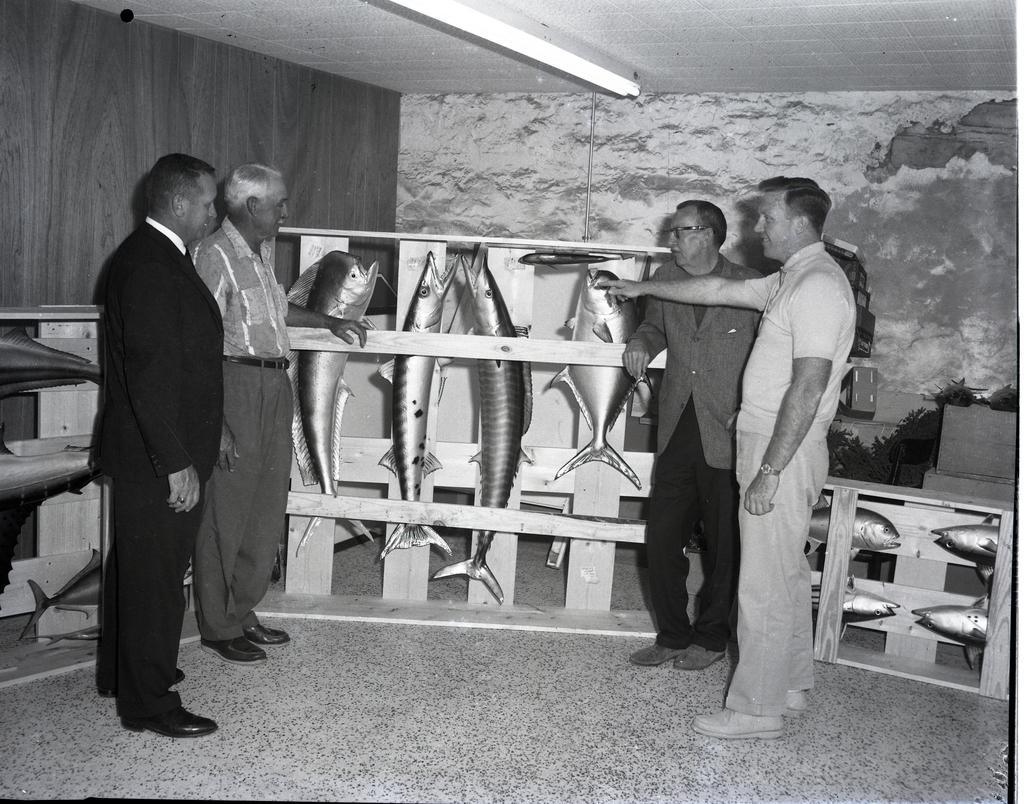Please provide a concise description of this image. This is a black and white image. There are four men standing. I think these are the sculptures of different types of fishes, which are on the wooden box. This looks like a wall. I think this is the tube light, which is attached to the roof. 